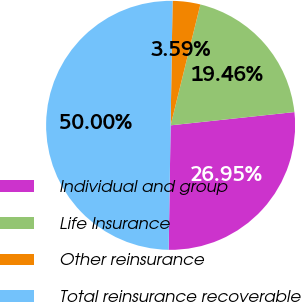Convert chart. <chart><loc_0><loc_0><loc_500><loc_500><pie_chart><fcel>Individual and group<fcel>Life Insurance<fcel>Other reinsurance<fcel>Total reinsurance recoverable<nl><fcel>26.95%<fcel>19.46%<fcel>3.59%<fcel>50.0%<nl></chart> 